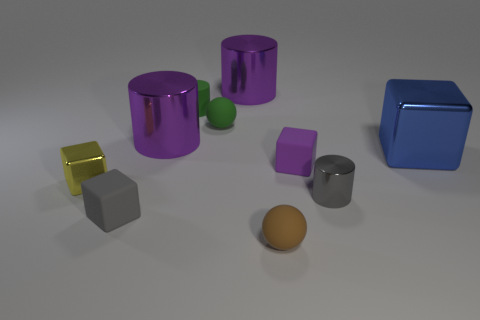How many other things are there of the same color as the tiny matte cylinder?
Provide a short and direct response. 1. What number of big cylinders are in front of the sphere behind the brown matte sphere?
Make the answer very short. 1. Are there any large purple shiny things to the right of the small green sphere?
Make the answer very short. Yes. What is the shape of the large object to the right of the small block behind the small yellow metallic thing?
Give a very brief answer. Cube. Are there fewer brown balls behind the big blue metal cube than purple shiny objects that are to the right of the tiny brown matte thing?
Your answer should be very brief. No. What is the color of the other tiny thing that is the same shape as the tiny gray metal thing?
Keep it short and to the point. Green. How many metallic objects are both behind the blue cube and in front of the blue shiny block?
Offer a very short reply. 0. Is the number of small yellow metallic things that are to the right of the green cylinder greater than the number of gray cylinders to the right of the gray cylinder?
Offer a terse response. No. How big is the gray metal thing?
Offer a terse response. Small. Is there a small yellow shiny thing of the same shape as the small brown rubber thing?
Your answer should be very brief. No. 